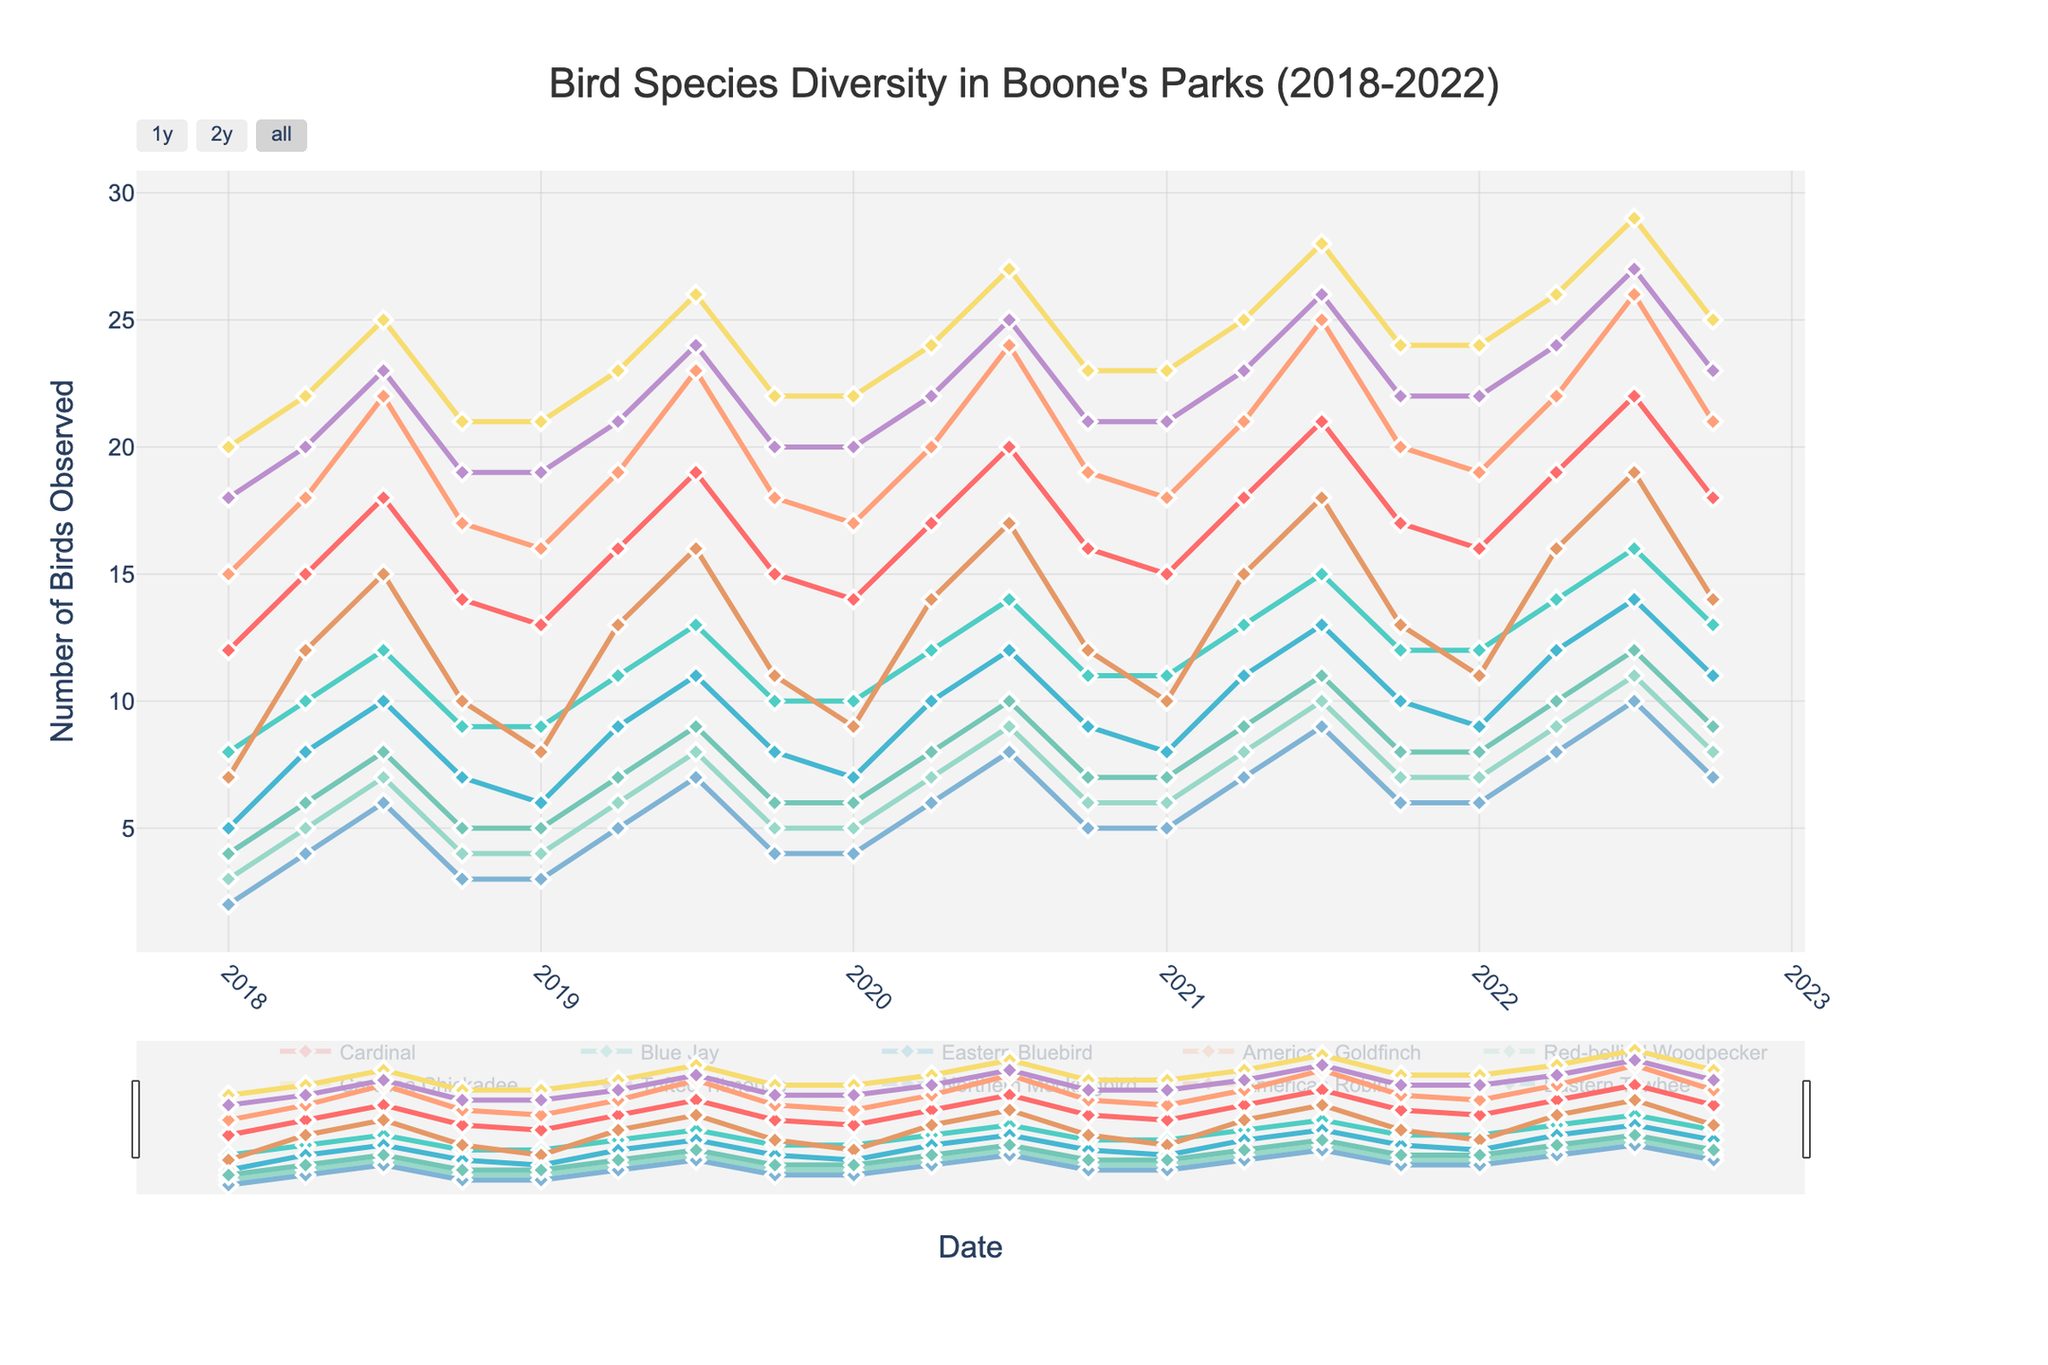Which bird species was observed the most in July 2022? In July 2022, look for the month of July under the year 2022. Follow the lines on the plot to see which species has the highest peak. The Carolina Chickadee has the highest peak among others.
Answer: Carolina Chickadee What is the difference between the number of Carolina Chickadees and American Robins observed in April 2020? Find the counts for both Carolina Chickadees and American Robins in April 2020. Carolina Chickadees were 24 and American Robins were 14. The difference is 24 - 14 = 10.
Answer: 10 Which species showed the most consistent number of observations across all months? Observing the patterns for each species, the Cardinal line shows the least fluctuation over time, indicating consistent observations.
Answer: Cardinal How did the number of Tufted Titmice observed change from January 2018 to July 2022? Find the values for Tufted Titmice in January 2018 and July 2022. In January 2018, there were 18 and in July 2022, there were 27. The change is 27 - 18 = 9.
Answer: Increased by 9 In which month and year was the observation peak for American Goldfinch? Look for the highest point on the American Goldfinch line. The peak occurs in July 2021.
Answer: July 2021 Was there a month where the number of Eastern Bluebirds was higher than the number of Red-bellied Woodpeckers? Compare the Eastern Bluebird and Red-bellied Woodpecker lines. One instance is in April 2018 where Eastern Bluebirds (8) > Red-bellied Woodpeckers (5).
Answer: Yes, April 2018 What trend do you see in the observations of the Northern Mockingbird from 2018 to 2022? Follow the Northern Mockingbird line from 2018 to 2022. Notice it starts lower and gradually increases with some fluctuations.
Answer: Increasing trend Which species had the lowest observation count in October 2018? Find the lowest peak for October 2018. The Northern Mockingbird had the lowest count with 3 observations.
Answer: Northern Mockingbird 